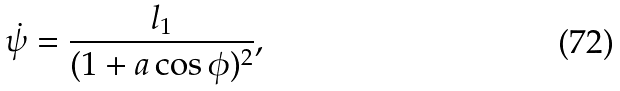Convert formula to latex. <formula><loc_0><loc_0><loc_500><loc_500>\dot { \psi } = \frac { l _ { 1 } } { ( 1 + a \cos \phi ) ^ { 2 } } ,</formula> 